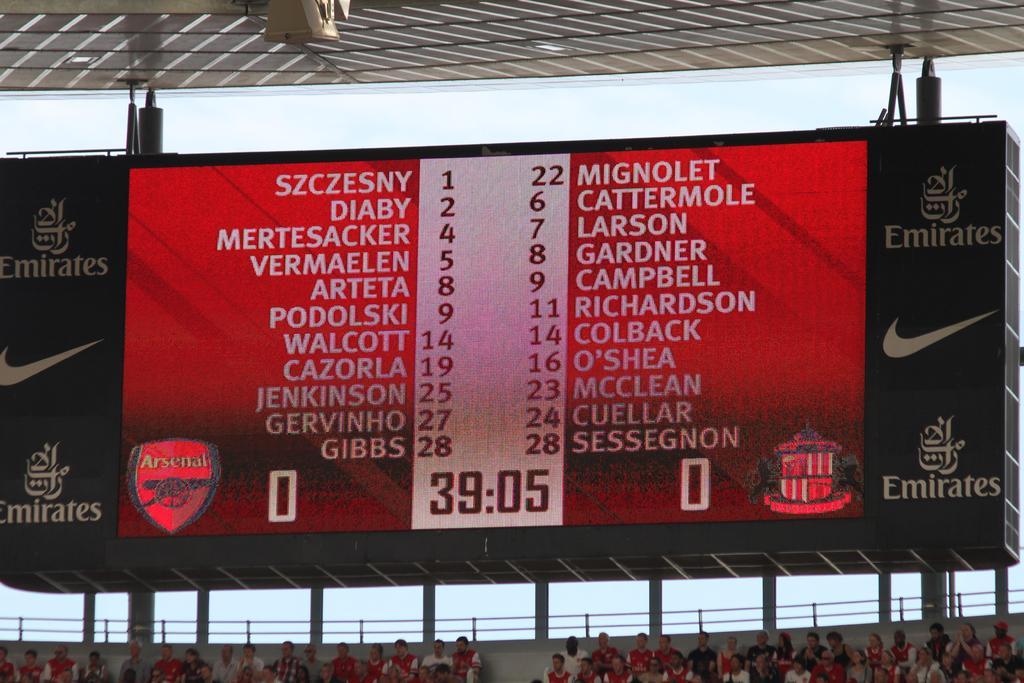Can you describe this image briefly? In the foreground of this image, there is a screen to the ceiling. On the bottom, there is the crowd sitting, a railing and the sky in the background, 